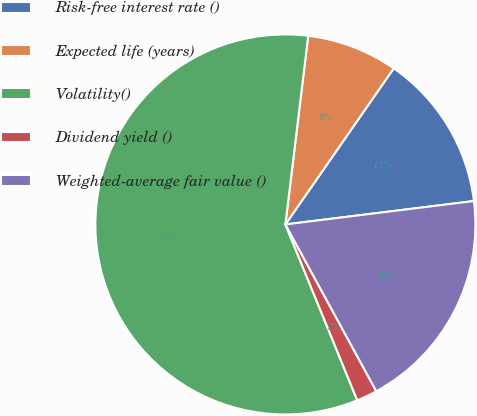Convert chart. <chart><loc_0><loc_0><loc_500><loc_500><pie_chart><fcel>Risk-free interest rate ()<fcel>Expected life (years)<fcel>Volatility()<fcel>Dividend yield ()<fcel>Weighted-average fair value ()<nl><fcel>13.38%<fcel>7.74%<fcel>58.09%<fcel>1.77%<fcel>19.02%<nl></chart> 